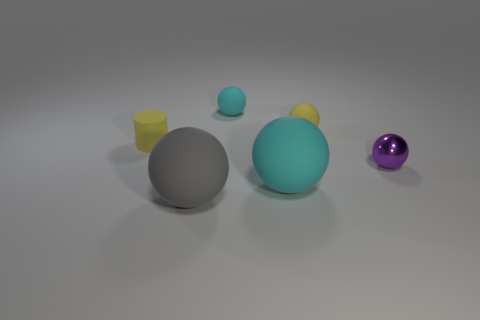There is a ball that is the same color as the cylinder; what is it made of?
Provide a short and direct response. Rubber. Is the size of the cyan matte thing behind the purple metallic ball the same as the cyan sphere in front of the small purple thing?
Provide a short and direct response. No. What number of things are in front of the yellow ball and behind the purple sphere?
Give a very brief answer. 1. There is another shiny thing that is the same shape as the big cyan object; what color is it?
Provide a succinct answer. Purple. Is the number of gray spheres less than the number of large rubber objects?
Give a very brief answer. Yes. Does the yellow ball have the same size as the yellow matte object that is on the left side of the big cyan matte ball?
Your response must be concise. Yes. What is the color of the tiny rubber thing that is to the right of the cyan rubber thing that is behind the metallic object?
Your answer should be very brief. Yellow. How many objects are either cyan matte things in front of the purple shiny object or small objects that are left of the tiny purple ball?
Your response must be concise. 4. Is the size of the shiny ball the same as the yellow ball?
Give a very brief answer. Yes. Is there any other thing that has the same size as the gray sphere?
Offer a very short reply. Yes. 